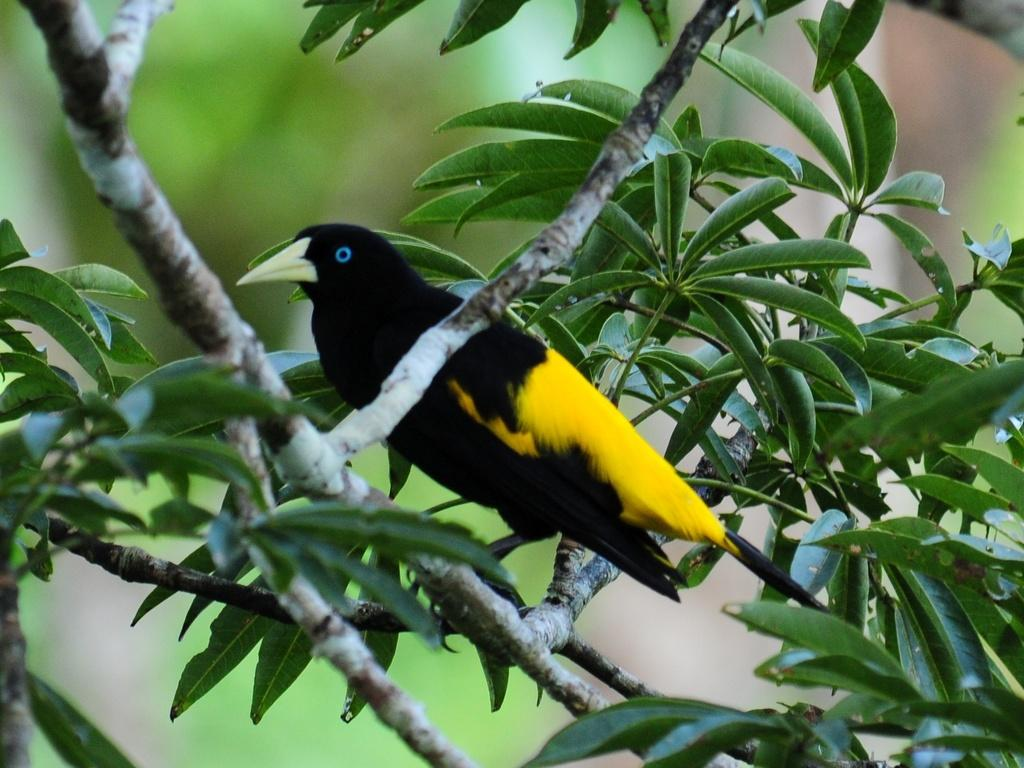What type of animal can be seen in the image? There is a bird in the image. Where is the bird located? The bird is on a branch of a tree. Can you describe the background of the image? The background of the image is blurry. What type of heart can be seen beating in the bird's elbow in the image? There is no heart or elbow visible in the image, as it features a bird on a tree branch with a blurry background. 